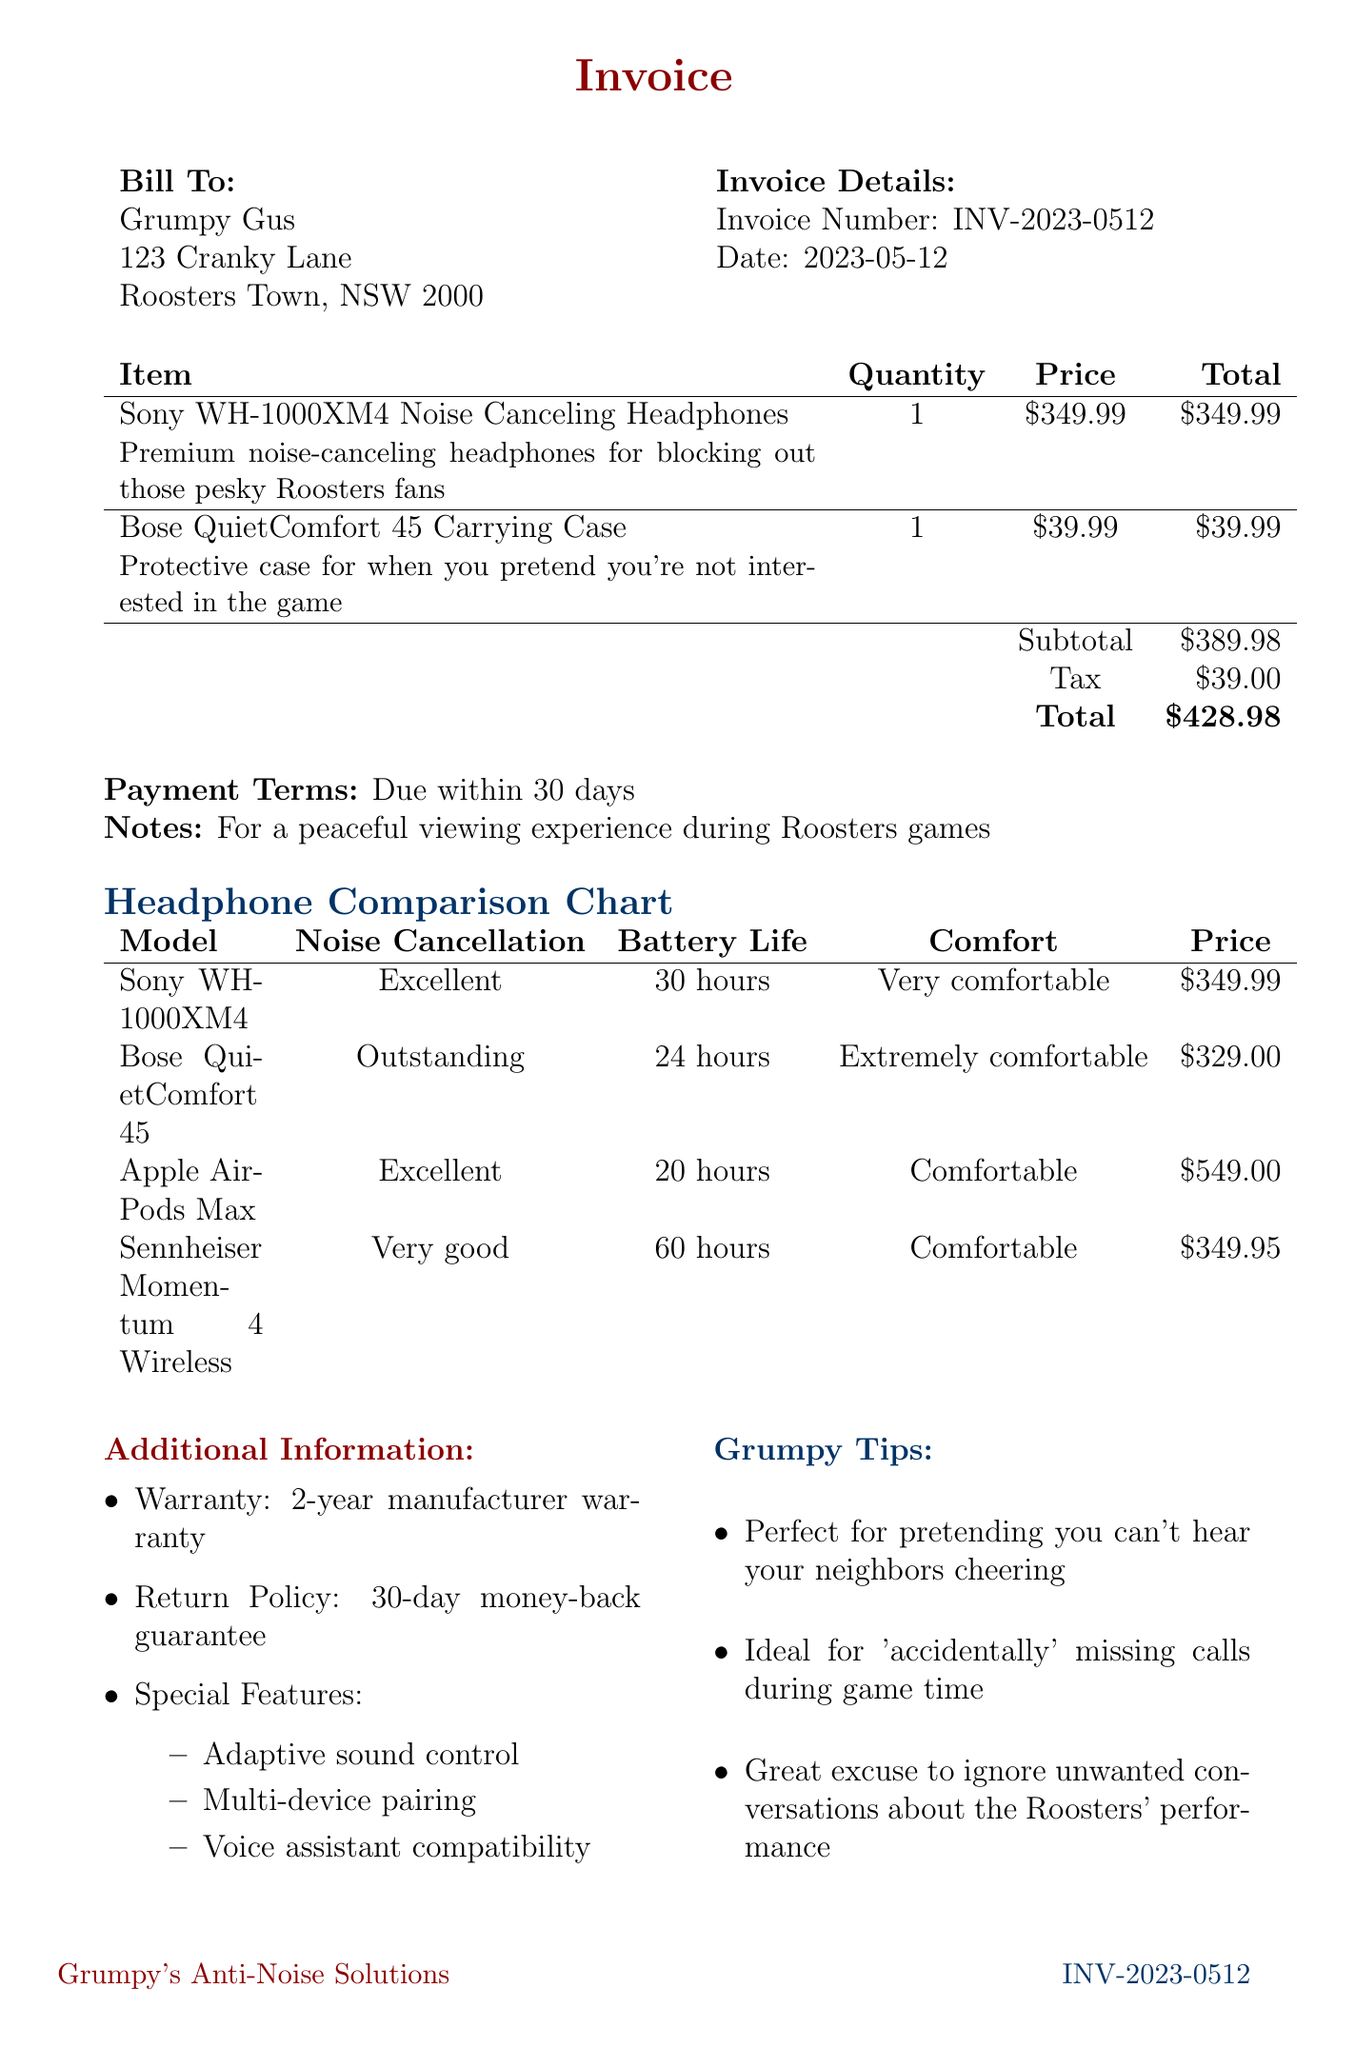What is the invoice number? The invoice number is specified in the document under "Invoice Number."
Answer: INV-2023-0512 Who is the customer? The customer's name is provided in the "Bill To" section of the document.
Answer: Grumpy Gus What is the total amount due? The total amount due is calculated as the sum of the subtotal and tax in the invoice.
Answer: $428.98 What is the battery life of the Sony WH-1000XM4? The battery life is mentioned in the comparison chart specifically for that model.
Answer: 30 hours Which model has the highest noise cancellation rating? The noise cancellation ratings are compared in the chart, highlighting the best-rated model.
Answer: Bose QuietComfort 45 What is the warranty period for the headphones? The warranty information is included in the "Additional Information" section of the invoice.
Answer: 2-year manufacturer warranty What is the purpose of the Bose QuietComfort 45 Carrying Case? The description of the item gives its intended use as stated in the invoice.
Answer: Protective case for when you pretend you're not interested in the game What special feature is mentioned for the headphones? The document lists special features in the "Additional Information" section.
Answer: Adaptive sound control How much tax is applied to the invoice? The tax amount is given separately in the invoice's financial summary.
Answer: $39.00 